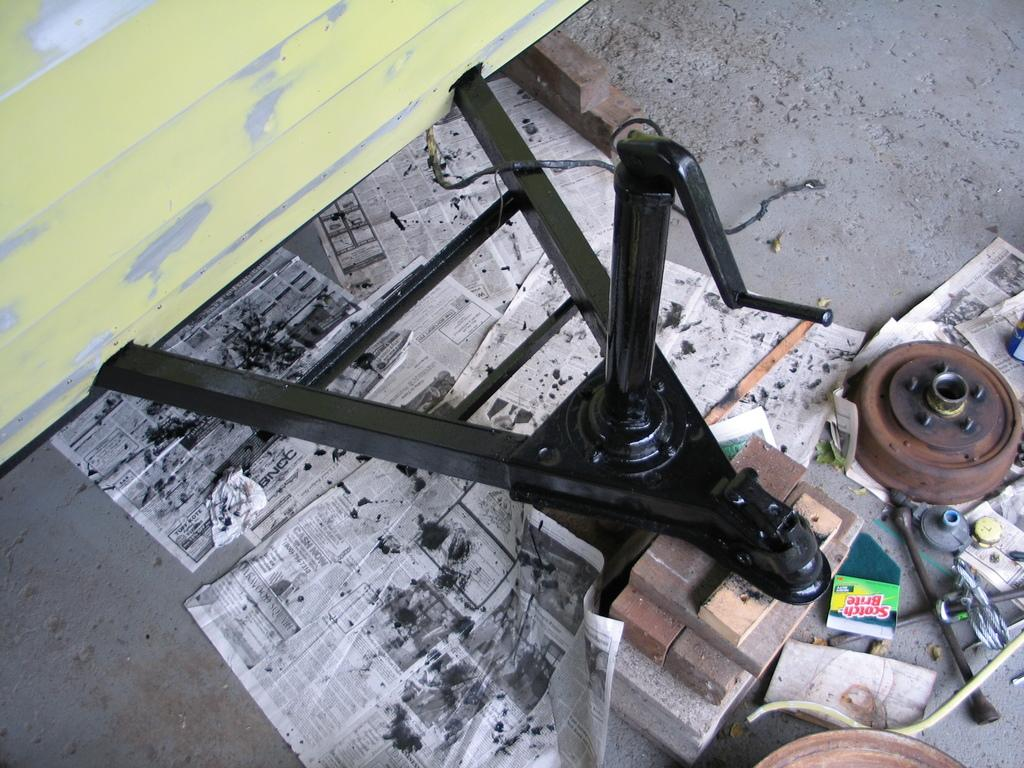What type of objects can be seen on the floor in the image? There are papers, wooden blocks, and a scotch pride on the floor. Are there any other objects visible on the floor? Yes, there are a few other objects on the floor. What type of shop can be seen in the background of the image? There is no shop visible in the image; it only shows objects on the floor. What title is given to the wooden blocks in the image? The wooden blocks do not have a specific title in the image; they are simply wooden blocks. 